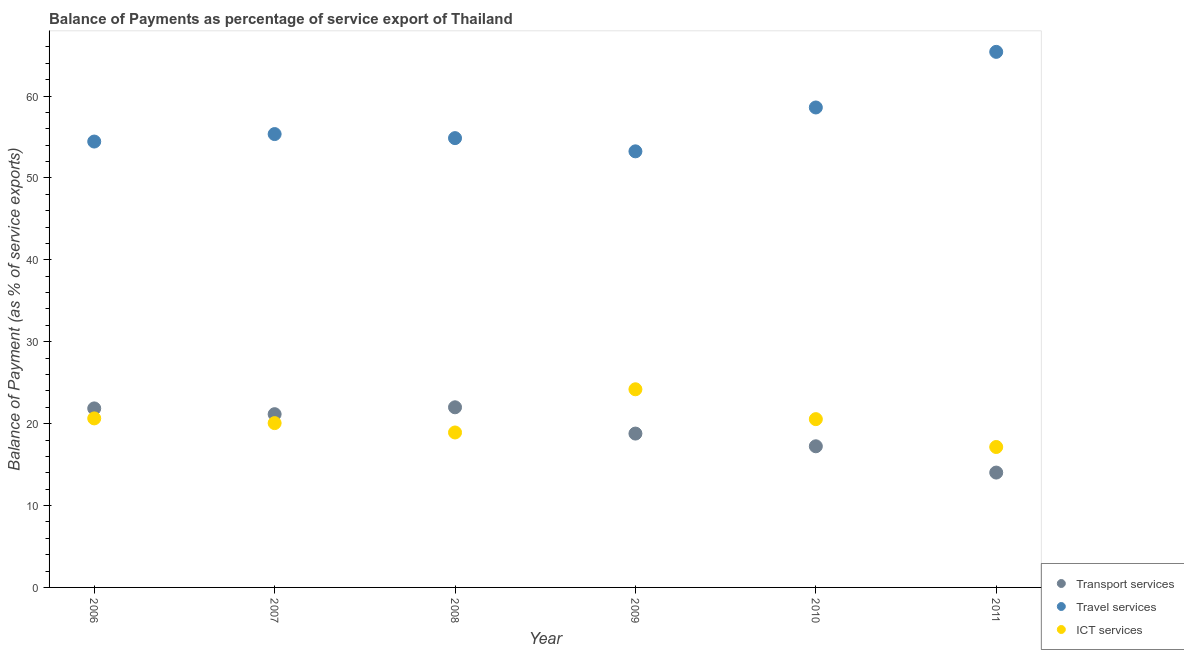What is the balance of payment of travel services in 2011?
Offer a terse response. 65.39. Across all years, what is the maximum balance of payment of transport services?
Give a very brief answer. 22. Across all years, what is the minimum balance of payment of travel services?
Offer a terse response. 53.25. In which year was the balance of payment of ict services maximum?
Offer a terse response. 2009. What is the total balance of payment of travel services in the graph?
Provide a succinct answer. 341.9. What is the difference between the balance of payment of travel services in 2006 and that in 2011?
Offer a terse response. -10.95. What is the difference between the balance of payment of travel services in 2011 and the balance of payment of ict services in 2007?
Your answer should be very brief. 45.33. What is the average balance of payment of travel services per year?
Offer a very short reply. 56.98. In the year 2007, what is the difference between the balance of payment of transport services and balance of payment of travel services?
Keep it short and to the point. -34.2. In how many years, is the balance of payment of ict services greater than 54 %?
Your answer should be very brief. 0. What is the ratio of the balance of payment of travel services in 2010 to that in 2011?
Your answer should be very brief. 0.9. What is the difference between the highest and the second highest balance of payment of travel services?
Your response must be concise. 6.79. What is the difference between the highest and the lowest balance of payment of travel services?
Offer a terse response. 12.15. How many dotlines are there?
Offer a terse response. 3. How many years are there in the graph?
Your answer should be compact. 6. Are the values on the major ticks of Y-axis written in scientific E-notation?
Your answer should be compact. No. Where does the legend appear in the graph?
Your answer should be very brief. Bottom right. How are the legend labels stacked?
Make the answer very short. Vertical. What is the title of the graph?
Give a very brief answer. Balance of Payments as percentage of service export of Thailand. What is the label or title of the Y-axis?
Offer a very short reply. Balance of Payment (as % of service exports). What is the Balance of Payment (as % of service exports) in Transport services in 2006?
Your answer should be very brief. 21.86. What is the Balance of Payment (as % of service exports) of Travel services in 2006?
Provide a short and direct response. 54.44. What is the Balance of Payment (as % of service exports) in ICT services in 2006?
Offer a very short reply. 20.64. What is the Balance of Payment (as % of service exports) in Transport services in 2007?
Your response must be concise. 21.15. What is the Balance of Payment (as % of service exports) of Travel services in 2007?
Ensure brevity in your answer.  55.36. What is the Balance of Payment (as % of service exports) in ICT services in 2007?
Offer a very short reply. 20.06. What is the Balance of Payment (as % of service exports) of Transport services in 2008?
Keep it short and to the point. 22. What is the Balance of Payment (as % of service exports) in Travel services in 2008?
Offer a very short reply. 54.86. What is the Balance of Payment (as % of service exports) in ICT services in 2008?
Your answer should be compact. 18.92. What is the Balance of Payment (as % of service exports) of Transport services in 2009?
Provide a succinct answer. 18.79. What is the Balance of Payment (as % of service exports) in Travel services in 2009?
Your answer should be very brief. 53.25. What is the Balance of Payment (as % of service exports) in ICT services in 2009?
Give a very brief answer. 24.19. What is the Balance of Payment (as % of service exports) of Transport services in 2010?
Your response must be concise. 17.23. What is the Balance of Payment (as % of service exports) of Travel services in 2010?
Keep it short and to the point. 58.6. What is the Balance of Payment (as % of service exports) of ICT services in 2010?
Your response must be concise. 20.55. What is the Balance of Payment (as % of service exports) in Transport services in 2011?
Your answer should be very brief. 14.02. What is the Balance of Payment (as % of service exports) in Travel services in 2011?
Your answer should be very brief. 65.39. What is the Balance of Payment (as % of service exports) of ICT services in 2011?
Keep it short and to the point. 17.15. Across all years, what is the maximum Balance of Payment (as % of service exports) in Transport services?
Make the answer very short. 22. Across all years, what is the maximum Balance of Payment (as % of service exports) in Travel services?
Give a very brief answer. 65.39. Across all years, what is the maximum Balance of Payment (as % of service exports) in ICT services?
Ensure brevity in your answer.  24.19. Across all years, what is the minimum Balance of Payment (as % of service exports) of Transport services?
Offer a very short reply. 14.02. Across all years, what is the minimum Balance of Payment (as % of service exports) of Travel services?
Make the answer very short. 53.25. Across all years, what is the minimum Balance of Payment (as % of service exports) of ICT services?
Ensure brevity in your answer.  17.15. What is the total Balance of Payment (as % of service exports) in Transport services in the graph?
Keep it short and to the point. 115.05. What is the total Balance of Payment (as % of service exports) of Travel services in the graph?
Keep it short and to the point. 341.9. What is the total Balance of Payment (as % of service exports) of ICT services in the graph?
Ensure brevity in your answer.  121.51. What is the difference between the Balance of Payment (as % of service exports) of Transport services in 2006 and that in 2007?
Your response must be concise. 0.7. What is the difference between the Balance of Payment (as % of service exports) of Travel services in 2006 and that in 2007?
Give a very brief answer. -0.91. What is the difference between the Balance of Payment (as % of service exports) of ICT services in 2006 and that in 2007?
Provide a short and direct response. 0.58. What is the difference between the Balance of Payment (as % of service exports) of Transport services in 2006 and that in 2008?
Your answer should be very brief. -0.14. What is the difference between the Balance of Payment (as % of service exports) of Travel services in 2006 and that in 2008?
Offer a very short reply. -0.42. What is the difference between the Balance of Payment (as % of service exports) in ICT services in 2006 and that in 2008?
Offer a terse response. 1.72. What is the difference between the Balance of Payment (as % of service exports) of Transport services in 2006 and that in 2009?
Offer a terse response. 3.07. What is the difference between the Balance of Payment (as % of service exports) in Travel services in 2006 and that in 2009?
Provide a succinct answer. 1.2. What is the difference between the Balance of Payment (as % of service exports) of ICT services in 2006 and that in 2009?
Provide a short and direct response. -3.56. What is the difference between the Balance of Payment (as % of service exports) in Transport services in 2006 and that in 2010?
Your answer should be very brief. 4.62. What is the difference between the Balance of Payment (as % of service exports) in Travel services in 2006 and that in 2010?
Give a very brief answer. -4.16. What is the difference between the Balance of Payment (as % of service exports) of ICT services in 2006 and that in 2010?
Your answer should be very brief. 0.09. What is the difference between the Balance of Payment (as % of service exports) in Transport services in 2006 and that in 2011?
Offer a very short reply. 7.83. What is the difference between the Balance of Payment (as % of service exports) in Travel services in 2006 and that in 2011?
Keep it short and to the point. -10.95. What is the difference between the Balance of Payment (as % of service exports) in ICT services in 2006 and that in 2011?
Offer a very short reply. 3.49. What is the difference between the Balance of Payment (as % of service exports) in Transport services in 2007 and that in 2008?
Offer a very short reply. -0.84. What is the difference between the Balance of Payment (as % of service exports) of Travel services in 2007 and that in 2008?
Provide a succinct answer. 0.5. What is the difference between the Balance of Payment (as % of service exports) of ICT services in 2007 and that in 2008?
Offer a terse response. 1.14. What is the difference between the Balance of Payment (as % of service exports) of Transport services in 2007 and that in 2009?
Provide a short and direct response. 2.37. What is the difference between the Balance of Payment (as % of service exports) in Travel services in 2007 and that in 2009?
Provide a short and direct response. 2.11. What is the difference between the Balance of Payment (as % of service exports) of ICT services in 2007 and that in 2009?
Provide a short and direct response. -4.13. What is the difference between the Balance of Payment (as % of service exports) in Transport services in 2007 and that in 2010?
Make the answer very short. 3.92. What is the difference between the Balance of Payment (as % of service exports) in Travel services in 2007 and that in 2010?
Make the answer very short. -3.25. What is the difference between the Balance of Payment (as % of service exports) in ICT services in 2007 and that in 2010?
Make the answer very short. -0.48. What is the difference between the Balance of Payment (as % of service exports) in Transport services in 2007 and that in 2011?
Ensure brevity in your answer.  7.13. What is the difference between the Balance of Payment (as % of service exports) of Travel services in 2007 and that in 2011?
Your answer should be very brief. -10.04. What is the difference between the Balance of Payment (as % of service exports) of ICT services in 2007 and that in 2011?
Your answer should be very brief. 2.92. What is the difference between the Balance of Payment (as % of service exports) in Transport services in 2008 and that in 2009?
Ensure brevity in your answer.  3.21. What is the difference between the Balance of Payment (as % of service exports) of Travel services in 2008 and that in 2009?
Offer a terse response. 1.61. What is the difference between the Balance of Payment (as % of service exports) of ICT services in 2008 and that in 2009?
Offer a very short reply. -5.27. What is the difference between the Balance of Payment (as % of service exports) in Transport services in 2008 and that in 2010?
Your response must be concise. 4.76. What is the difference between the Balance of Payment (as % of service exports) in Travel services in 2008 and that in 2010?
Offer a very short reply. -3.74. What is the difference between the Balance of Payment (as % of service exports) of ICT services in 2008 and that in 2010?
Ensure brevity in your answer.  -1.63. What is the difference between the Balance of Payment (as % of service exports) in Transport services in 2008 and that in 2011?
Provide a short and direct response. 7.97. What is the difference between the Balance of Payment (as % of service exports) in Travel services in 2008 and that in 2011?
Keep it short and to the point. -10.53. What is the difference between the Balance of Payment (as % of service exports) in ICT services in 2008 and that in 2011?
Keep it short and to the point. 1.77. What is the difference between the Balance of Payment (as % of service exports) of Transport services in 2009 and that in 2010?
Give a very brief answer. 1.55. What is the difference between the Balance of Payment (as % of service exports) in Travel services in 2009 and that in 2010?
Your response must be concise. -5.36. What is the difference between the Balance of Payment (as % of service exports) in ICT services in 2009 and that in 2010?
Offer a terse response. 3.65. What is the difference between the Balance of Payment (as % of service exports) in Transport services in 2009 and that in 2011?
Your answer should be very brief. 4.76. What is the difference between the Balance of Payment (as % of service exports) in Travel services in 2009 and that in 2011?
Give a very brief answer. -12.15. What is the difference between the Balance of Payment (as % of service exports) of ICT services in 2009 and that in 2011?
Your response must be concise. 7.05. What is the difference between the Balance of Payment (as % of service exports) of Transport services in 2010 and that in 2011?
Keep it short and to the point. 3.21. What is the difference between the Balance of Payment (as % of service exports) of Travel services in 2010 and that in 2011?
Ensure brevity in your answer.  -6.79. What is the difference between the Balance of Payment (as % of service exports) in ICT services in 2010 and that in 2011?
Ensure brevity in your answer.  3.4. What is the difference between the Balance of Payment (as % of service exports) of Transport services in 2006 and the Balance of Payment (as % of service exports) of Travel services in 2007?
Give a very brief answer. -33.5. What is the difference between the Balance of Payment (as % of service exports) of Transport services in 2006 and the Balance of Payment (as % of service exports) of ICT services in 2007?
Provide a short and direct response. 1.79. What is the difference between the Balance of Payment (as % of service exports) in Travel services in 2006 and the Balance of Payment (as % of service exports) in ICT services in 2007?
Offer a terse response. 34.38. What is the difference between the Balance of Payment (as % of service exports) of Transport services in 2006 and the Balance of Payment (as % of service exports) of Travel services in 2008?
Give a very brief answer. -33. What is the difference between the Balance of Payment (as % of service exports) of Transport services in 2006 and the Balance of Payment (as % of service exports) of ICT services in 2008?
Ensure brevity in your answer.  2.94. What is the difference between the Balance of Payment (as % of service exports) in Travel services in 2006 and the Balance of Payment (as % of service exports) in ICT services in 2008?
Provide a short and direct response. 35.52. What is the difference between the Balance of Payment (as % of service exports) in Transport services in 2006 and the Balance of Payment (as % of service exports) in Travel services in 2009?
Offer a terse response. -31.39. What is the difference between the Balance of Payment (as % of service exports) of Transport services in 2006 and the Balance of Payment (as % of service exports) of ICT services in 2009?
Offer a very short reply. -2.34. What is the difference between the Balance of Payment (as % of service exports) in Travel services in 2006 and the Balance of Payment (as % of service exports) in ICT services in 2009?
Your response must be concise. 30.25. What is the difference between the Balance of Payment (as % of service exports) of Transport services in 2006 and the Balance of Payment (as % of service exports) of Travel services in 2010?
Provide a short and direct response. -36.74. What is the difference between the Balance of Payment (as % of service exports) in Transport services in 2006 and the Balance of Payment (as % of service exports) in ICT services in 2010?
Your answer should be compact. 1.31. What is the difference between the Balance of Payment (as % of service exports) of Travel services in 2006 and the Balance of Payment (as % of service exports) of ICT services in 2010?
Provide a succinct answer. 33.89. What is the difference between the Balance of Payment (as % of service exports) of Transport services in 2006 and the Balance of Payment (as % of service exports) of Travel services in 2011?
Provide a short and direct response. -43.54. What is the difference between the Balance of Payment (as % of service exports) in Transport services in 2006 and the Balance of Payment (as % of service exports) in ICT services in 2011?
Ensure brevity in your answer.  4.71. What is the difference between the Balance of Payment (as % of service exports) in Travel services in 2006 and the Balance of Payment (as % of service exports) in ICT services in 2011?
Your response must be concise. 37.3. What is the difference between the Balance of Payment (as % of service exports) in Transport services in 2007 and the Balance of Payment (as % of service exports) in Travel services in 2008?
Your answer should be compact. -33.71. What is the difference between the Balance of Payment (as % of service exports) of Transport services in 2007 and the Balance of Payment (as % of service exports) of ICT services in 2008?
Make the answer very short. 2.23. What is the difference between the Balance of Payment (as % of service exports) in Travel services in 2007 and the Balance of Payment (as % of service exports) in ICT services in 2008?
Your response must be concise. 36.44. What is the difference between the Balance of Payment (as % of service exports) of Transport services in 2007 and the Balance of Payment (as % of service exports) of Travel services in 2009?
Give a very brief answer. -32.09. What is the difference between the Balance of Payment (as % of service exports) of Transport services in 2007 and the Balance of Payment (as % of service exports) of ICT services in 2009?
Provide a short and direct response. -3.04. What is the difference between the Balance of Payment (as % of service exports) of Travel services in 2007 and the Balance of Payment (as % of service exports) of ICT services in 2009?
Provide a short and direct response. 31.16. What is the difference between the Balance of Payment (as % of service exports) in Transport services in 2007 and the Balance of Payment (as % of service exports) in Travel services in 2010?
Provide a succinct answer. -37.45. What is the difference between the Balance of Payment (as % of service exports) of Transport services in 2007 and the Balance of Payment (as % of service exports) of ICT services in 2010?
Your response must be concise. 0.61. What is the difference between the Balance of Payment (as % of service exports) in Travel services in 2007 and the Balance of Payment (as % of service exports) in ICT services in 2010?
Offer a very short reply. 34.81. What is the difference between the Balance of Payment (as % of service exports) of Transport services in 2007 and the Balance of Payment (as % of service exports) of Travel services in 2011?
Keep it short and to the point. -44.24. What is the difference between the Balance of Payment (as % of service exports) of Transport services in 2007 and the Balance of Payment (as % of service exports) of ICT services in 2011?
Offer a terse response. 4.01. What is the difference between the Balance of Payment (as % of service exports) of Travel services in 2007 and the Balance of Payment (as % of service exports) of ICT services in 2011?
Provide a short and direct response. 38.21. What is the difference between the Balance of Payment (as % of service exports) in Transport services in 2008 and the Balance of Payment (as % of service exports) in Travel services in 2009?
Your answer should be very brief. -31.25. What is the difference between the Balance of Payment (as % of service exports) in Transport services in 2008 and the Balance of Payment (as % of service exports) in ICT services in 2009?
Ensure brevity in your answer.  -2.2. What is the difference between the Balance of Payment (as % of service exports) in Travel services in 2008 and the Balance of Payment (as % of service exports) in ICT services in 2009?
Give a very brief answer. 30.67. What is the difference between the Balance of Payment (as % of service exports) in Transport services in 2008 and the Balance of Payment (as % of service exports) in Travel services in 2010?
Ensure brevity in your answer.  -36.61. What is the difference between the Balance of Payment (as % of service exports) of Transport services in 2008 and the Balance of Payment (as % of service exports) of ICT services in 2010?
Give a very brief answer. 1.45. What is the difference between the Balance of Payment (as % of service exports) in Travel services in 2008 and the Balance of Payment (as % of service exports) in ICT services in 2010?
Your answer should be compact. 34.31. What is the difference between the Balance of Payment (as % of service exports) of Transport services in 2008 and the Balance of Payment (as % of service exports) of Travel services in 2011?
Your answer should be compact. -43.4. What is the difference between the Balance of Payment (as % of service exports) in Transport services in 2008 and the Balance of Payment (as % of service exports) in ICT services in 2011?
Your answer should be very brief. 4.85. What is the difference between the Balance of Payment (as % of service exports) in Travel services in 2008 and the Balance of Payment (as % of service exports) in ICT services in 2011?
Your answer should be compact. 37.71. What is the difference between the Balance of Payment (as % of service exports) in Transport services in 2009 and the Balance of Payment (as % of service exports) in Travel services in 2010?
Your answer should be compact. -39.82. What is the difference between the Balance of Payment (as % of service exports) in Transport services in 2009 and the Balance of Payment (as % of service exports) in ICT services in 2010?
Offer a very short reply. -1.76. What is the difference between the Balance of Payment (as % of service exports) of Travel services in 2009 and the Balance of Payment (as % of service exports) of ICT services in 2010?
Your answer should be very brief. 32.7. What is the difference between the Balance of Payment (as % of service exports) in Transport services in 2009 and the Balance of Payment (as % of service exports) in Travel services in 2011?
Your answer should be very brief. -46.61. What is the difference between the Balance of Payment (as % of service exports) of Transport services in 2009 and the Balance of Payment (as % of service exports) of ICT services in 2011?
Keep it short and to the point. 1.64. What is the difference between the Balance of Payment (as % of service exports) in Travel services in 2009 and the Balance of Payment (as % of service exports) in ICT services in 2011?
Give a very brief answer. 36.1. What is the difference between the Balance of Payment (as % of service exports) in Transport services in 2010 and the Balance of Payment (as % of service exports) in Travel services in 2011?
Offer a very short reply. -48.16. What is the difference between the Balance of Payment (as % of service exports) in Transport services in 2010 and the Balance of Payment (as % of service exports) in ICT services in 2011?
Keep it short and to the point. 0.09. What is the difference between the Balance of Payment (as % of service exports) in Travel services in 2010 and the Balance of Payment (as % of service exports) in ICT services in 2011?
Ensure brevity in your answer.  41.46. What is the average Balance of Payment (as % of service exports) of Transport services per year?
Your response must be concise. 19.18. What is the average Balance of Payment (as % of service exports) in Travel services per year?
Provide a short and direct response. 56.98. What is the average Balance of Payment (as % of service exports) in ICT services per year?
Provide a short and direct response. 20.25. In the year 2006, what is the difference between the Balance of Payment (as % of service exports) in Transport services and Balance of Payment (as % of service exports) in Travel services?
Give a very brief answer. -32.58. In the year 2006, what is the difference between the Balance of Payment (as % of service exports) in Transport services and Balance of Payment (as % of service exports) in ICT services?
Give a very brief answer. 1.22. In the year 2006, what is the difference between the Balance of Payment (as % of service exports) in Travel services and Balance of Payment (as % of service exports) in ICT services?
Offer a very short reply. 33.8. In the year 2007, what is the difference between the Balance of Payment (as % of service exports) of Transport services and Balance of Payment (as % of service exports) of Travel services?
Provide a short and direct response. -34.2. In the year 2007, what is the difference between the Balance of Payment (as % of service exports) in Transport services and Balance of Payment (as % of service exports) in ICT services?
Offer a terse response. 1.09. In the year 2007, what is the difference between the Balance of Payment (as % of service exports) of Travel services and Balance of Payment (as % of service exports) of ICT services?
Your answer should be very brief. 35.29. In the year 2008, what is the difference between the Balance of Payment (as % of service exports) in Transport services and Balance of Payment (as % of service exports) in Travel services?
Offer a terse response. -32.87. In the year 2008, what is the difference between the Balance of Payment (as % of service exports) of Transport services and Balance of Payment (as % of service exports) of ICT services?
Your answer should be very brief. 3.08. In the year 2008, what is the difference between the Balance of Payment (as % of service exports) of Travel services and Balance of Payment (as % of service exports) of ICT services?
Provide a short and direct response. 35.94. In the year 2009, what is the difference between the Balance of Payment (as % of service exports) in Transport services and Balance of Payment (as % of service exports) in Travel services?
Keep it short and to the point. -34.46. In the year 2009, what is the difference between the Balance of Payment (as % of service exports) of Transport services and Balance of Payment (as % of service exports) of ICT services?
Provide a succinct answer. -5.41. In the year 2009, what is the difference between the Balance of Payment (as % of service exports) in Travel services and Balance of Payment (as % of service exports) in ICT services?
Your answer should be very brief. 29.05. In the year 2010, what is the difference between the Balance of Payment (as % of service exports) in Transport services and Balance of Payment (as % of service exports) in Travel services?
Provide a succinct answer. -41.37. In the year 2010, what is the difference between the Balance of Payment (as % of service exports) of Transport services and Balance of Payment (as % of service exports) of ICT services?
Offer a very short reply. -3.31. In the year 2010, what is the difference between the Balance of Payment (as % of service exports) of Travel services and Balance of Payment (as % of service exports) of ICT services?
Your answer should be very brief. 38.05. In the year 2011, what is the difference between the Balance of Payment (as % of service exports) of Transport services and Balance of Payment (as % of service exports) of Travel services?
Your answer should be compact. -51.37. In the year 2011, what is the difference between the Balance of Payment (as % of service exports) in Transport services and Balance of Payment (as % of service exports) in ICT services?
Provide a succinct answer. -3.12. In the year 2011, what is the difference between the Balance of Payment (as % of service exports) in Travel services and Balance of Payment (as % of service exports) in ICT services?
Keep it short and to the point. 48.25. What is the ratio of the Balance of Payment (as % of service exports) in Travel services in 2006 to that in 2007?
Your answer should be very brief. 0.98. What is the ratio of the Balance of Payment (as % of service exports) of ICT services in 2006 to that in 2007?
Make the answer very short. 1.03. What is the ratio of the Balance of Payment (as % of service exports) of Transport services in 2006 to that in 2008?
Keep it short and to the point. 0.99. What is the ratio of the Balance of Payment (as % of service exports) in Transport services in 2006 to that in 2009?
Offer a terse response. 1.16. What is the ratio of the Balance of Payment (as % of service exports) in Travel services in 2006 to that in 2009?
Keep it short and to the point. 1.02. What is the ratio of the Balance of Payment (as % of service exports) in ICT services in 2006 to that in 2009?
Your response must be concise. 0.85. What is the ratio of the Balance of Payment (as % of service exports) in Transport services in 2006 to that in 2010?
Your answer should be compact. 1.27. What is the ratio of the Balance of Payment (as % of service exports) in Travel services in 2006 to that in 2010?
Provide a short and direct response. 0.93. What is the ratio of the Balance of Payment (as % of service exports) in Transport services in 2006 to that in 2011?
Offer a very short reply. 1.56. What is the ratio of the Balance of Payment (as % of service exports) of Travel services in 2006 to that in 2011?
Your response must be concise. 0.83. What is the ratio of the Balance of Payment (as % of service exports) in ICT services in 2006 to that in 2011?
Offer a very short reply. 1.2. What is the ratio of the Balance of Payment (as % of service exports) in Transport services in 2007 to that in 2008?
Your response must be concise. 0.96. What is the ratio of the Balance of Payment (as % of service exports) in Travel services in 2007 to that in 2008?
Make the answer very short. 1.01. What is the ratio of the Balance of Payment (as % of service exports) in ICT services in 2007 to that in 2008?
Your answer should be very brief. 1.06. What is the ratio of the Balance of Payment (as % of service exports) in Transport services in 2007 to that in 2009?
Provide a succinct answer. 1.13. What is the ratio of the Balance of Payment (as % of service exports) in Travel services in 2007 to that in 2009?
Offer a terse response. 1.04. What is the ratio of the Balance of Payment (as % of service exports) of ICT services in 2007 to that in 2009?
Your response must be concise. 0.83. What is the ratio of the Balance of Payment (as % of service exports) of Transport services in 2007 to that in 2010?
Your response must be concise. 1.23. What is the ratio of the Balance of Payment (as % of service exports) of Travel services in 2007 to that in 2010?
Your answer should be very brief. 0.94. What is the ratio of the Balance of Payment (as % of service exports) of ICT services in 2007 to that in 2010?
Your response must be concise. 0.98. What is the ratio of the Balance of Payment (as % of service exports) in Transport services in 2007 to that in 2011?
Make the answer very short. 1.51. What is the ratio of the Balance of Payment (as % of service exports) in Travel services in 2007 to that in 2011?
Offer a terse response. 0.85. What is the ratio of the Balance of Payment (as % of service exports) in ICT services in 2007 to that in 2011?
Provide a succinct answer. 1.17. What is the ratio of the Balance of Payment (as % of service exports) of Transport services in 2008 to that in 2009?
Offer a very short reply. 1.17. What is the ratio of the Balance of Payment (as % of service exports) in Travel services in 2008 to that in 2009?
Offer a very short reply. 1.03. What is the ratio of the Balance of Payment (as % of service exports) of ICT services in 2008 to that in 2009?
Your answer should be very brief. 0.78. What is the ratio of the Balance of Payment (as % of service exports) of Transport services in 2008 to that in 2010?
Offer a terse response. 1.28. What is the ratio of the Balance of Payment (as % of service exports) in Travel services in 2008 to that in 2010?
Make the answer very short. 0.94. What is the ratio of the Balance of Payment (as % of service exports) of ICT services in 2008 to that in 2010?
Offer a very short reply. 0.92. What is the ratio of the Balance of Payment (as % of service exports) in Transport services in 2008 to that in 2011?
Make the answer very short. 1.57. What is the ratio of the Balance of Payment (as % of service exports) in Travel services in 2008 to that in 2011?
Your response must be concise. 0.84. What is the ratio of the Balance of Payment (as % of service exports) of ICT services in 2008 to that in 2011?
Keep it short and to the point. 1.1. What is the ratio of the Balance of Payment (as % of service exports) of Transport services in 2009 to that in 2010?
Give a very brief answer. 1.09. What is the ratio of the Balance of Payment (as % of service exports) of Travel services in 2009 to that in 2010?
Your answer should be compact. 0.91. What is the ratio of the Balance of Payment (as % of service exports) in ICT services in 2009 to that in 2010?
Give a very brief answer. 1.18. What is the ratio of the Balance of Payment (as % of service exports) of Transport services in 2009 to that in 2011?
Provide a succinct answer. 1.34. What is the ratio of the Balance of Payment (as % of service exports) of Travel services in 2009 to that in 2011?
Provide a succinct answer. 0.81. What is the ratio of the Balance of Payment (as % of service exports) in ICT services in 2009 to that in 2011?
Give a very brief answer. 1.41. What is the ratio of the Balance of Payment (as % of service exports) in Transport services in 2010 to that in 2011?
Your answer should be compact. 1.23. What is the ratio of the Balance of Payment (as % of service exports) in Travel services in 2010 to that in 2011?
Provide a succinct answer. 0.9. What is the ratio of the Balance of Payment (as % of service exports) of ICT services in 2010 to that in 2011?
Make the answer very short. 1.2. What is the difference between the highest and the second highest Balance of Payment (as % of service exports) in Transport services?
Your answer should be very brief. 0.14. What is the difference between the highest and the second highest Balance of Payment (as % of service exports) of Travel services?
Your answer should be compact. 6.79. What is the difference between the highest and the second highest Balance of Payment (as % of service exports) of ICT services?
Offer a very short reply. 3.56. What is the difference between the highest and the lowest Balance of Payment (as % of service exports) in Transport services?
Your answer should be compact. 7.97. What is the difference between the highest and the lowest Balance of Payment (as % of service exports) in Travel services?
Provide a succinct answer. 12.15. What is the difference between the highest and the lowest Balance of Payment (as % of service exports) of ICT services?
Keep it short and to the point. 7.05. 